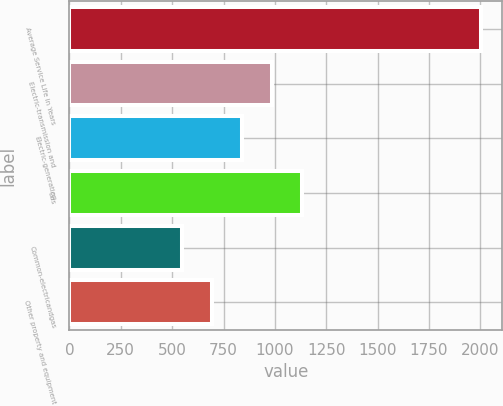Convert chart. <chart><loc_0><loc_0><loc_500><loc_500><bar_chart><fcel>Average Service Life in Years<fcel>Electric-transmission and<fcel>Electric-generation<fcel>Gas<fcel>Common-electricandgas<fcel>Other property and equipment<nl><fcel>2005<fcel>983.7<fcel>837.8<fcel>1129.6<fcel>546<fcel>691.9<nl></chart> 